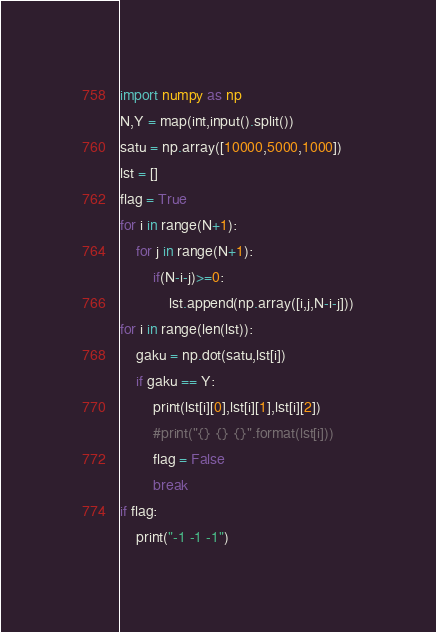<code> <loc_0><loc_0><loc_500><loc_500><_Python_>import numpy as np
N,Y = map(int,input().split())
satu = np.array([10000,5000,1000])
lst = []
flag = True
for i in range(N+1):
    for j in range(N+1):
        if(N-i-j)>=0:
            lst.append(np.array([i,j,N-i-j]))
for i in range(len(lst)):
    gaku = np.dot(satu,lst[i])
    if gaku == Y:
        print(lst[i][0],lst[i][1],lst[i][2])
        #print("{} {} {}".format(lst[i]))
        flag = False
        break
if flag:
    print("-1 -1 -1")
</code> 